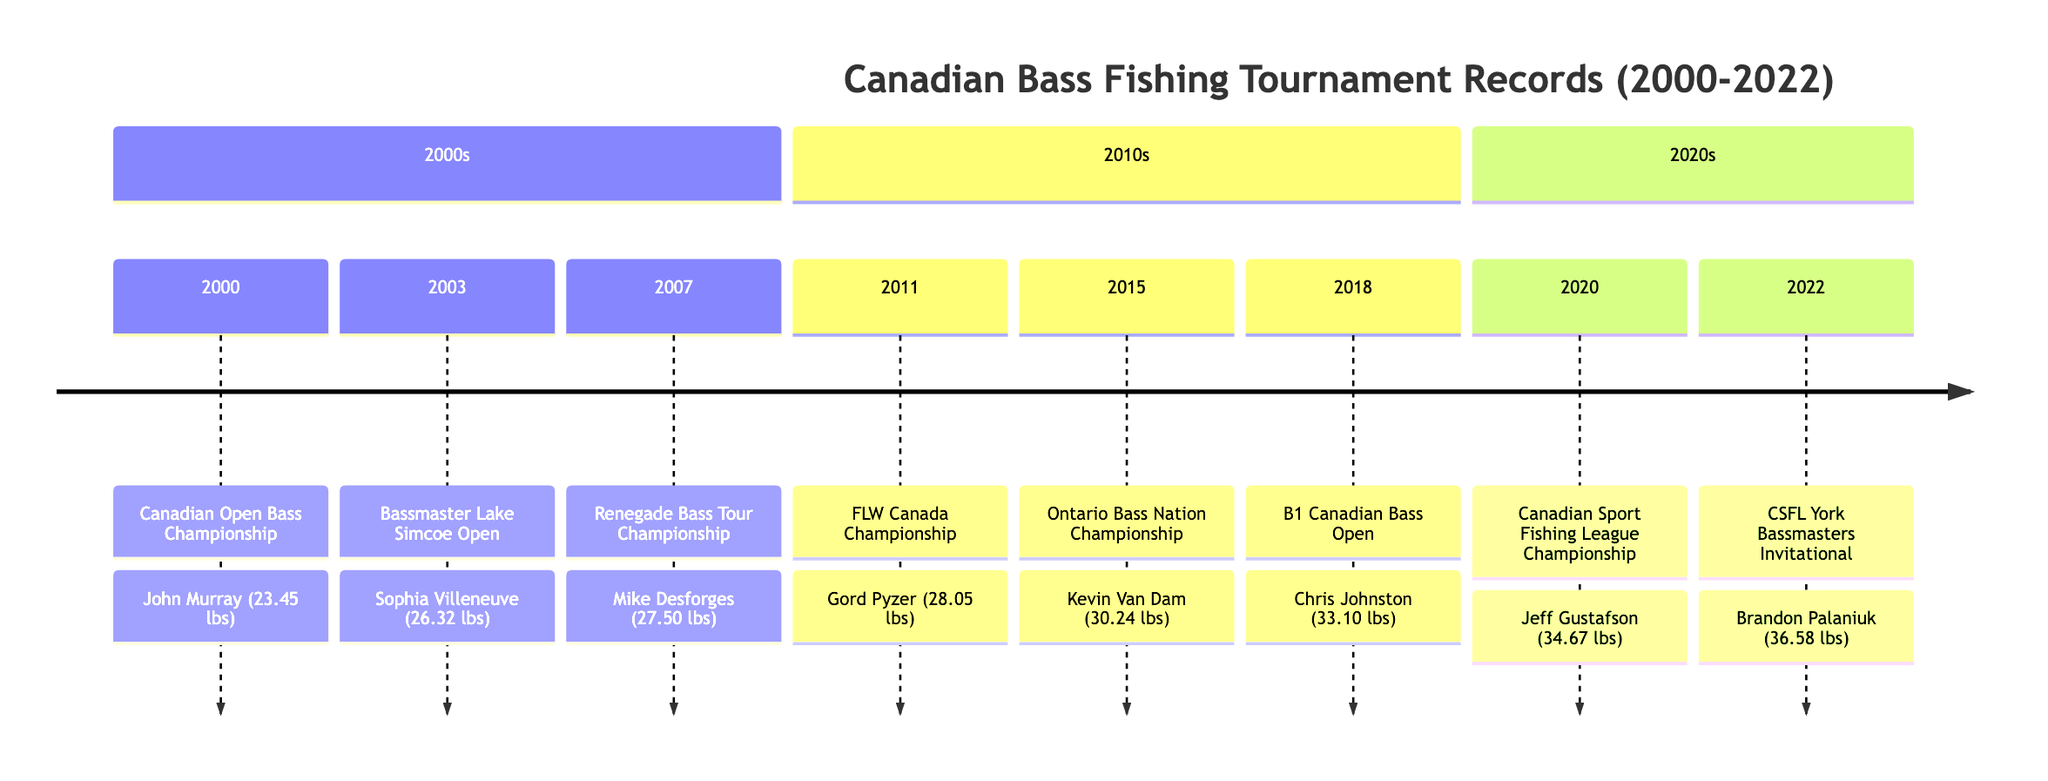What was the winning weight for the 2003 tournament? In the 2003 tournament, which is the Bassmaster Lake Simcoe Open, the record weight is mentioned as 26.32 lbs.
Answer: 26.32 lbs Who won the 2018 tournament? The 2018 tournament, the B1 Canadian Bass Open, was won by Chris Johnston.
Answer: Chris Johnston Which tournament had the highest record weight? By examining the timeline, the tournament with the highest record weight is the CSFL York Bassmasters Invitational in 2022, with a weight of 36.58 lbs.
Answer: 36.58 lbs How many tournaments happened in the 2000s? There are three tournaments listed in the section for the 2000s: the Canadian Open Bass Championship (2000), Bassmaster Lake Simcoe Open (2003), and Renegade Bass Tour Championship (2007), indicating a total of three tournaments.
Answer: 3 Which winner has the most recent tournament victory? In the timeline, the most recent tournament victory is held by Brandon Palaniuk, who won the CSFL York Bassmasters Invitational in 2022.
Answer: Brandon Palaniuk What is the year of the tournament with the second highest record weight? The tournament with the second highest record weight is the Canadian Sport Fishing League Championship held in 2020, with a weight of 34.67 lbs. Thus, the year of this tournament is 2020.
Answer: 2020 Which location hosted the 2007 tournament? The 2007 tournament, which is the Renegade Bass Tour Championship, took place at Newboro Lake, Ontario, as indicated in the timeline.
Answer: Newboro Lake, Ontario How much did the winner of the 2015 tournament weigh? According to the timeline, the winner of the 2015 Ontario Bass Nation Championship achieved a record weight of 30.24 lbs.
Answer: 30.24 lbs 